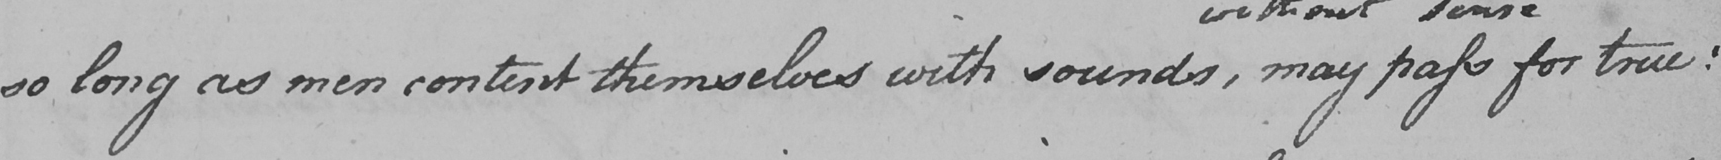Please provide the text content of this handwritten line. so long as men content themselves with sounds , may pass for true : 